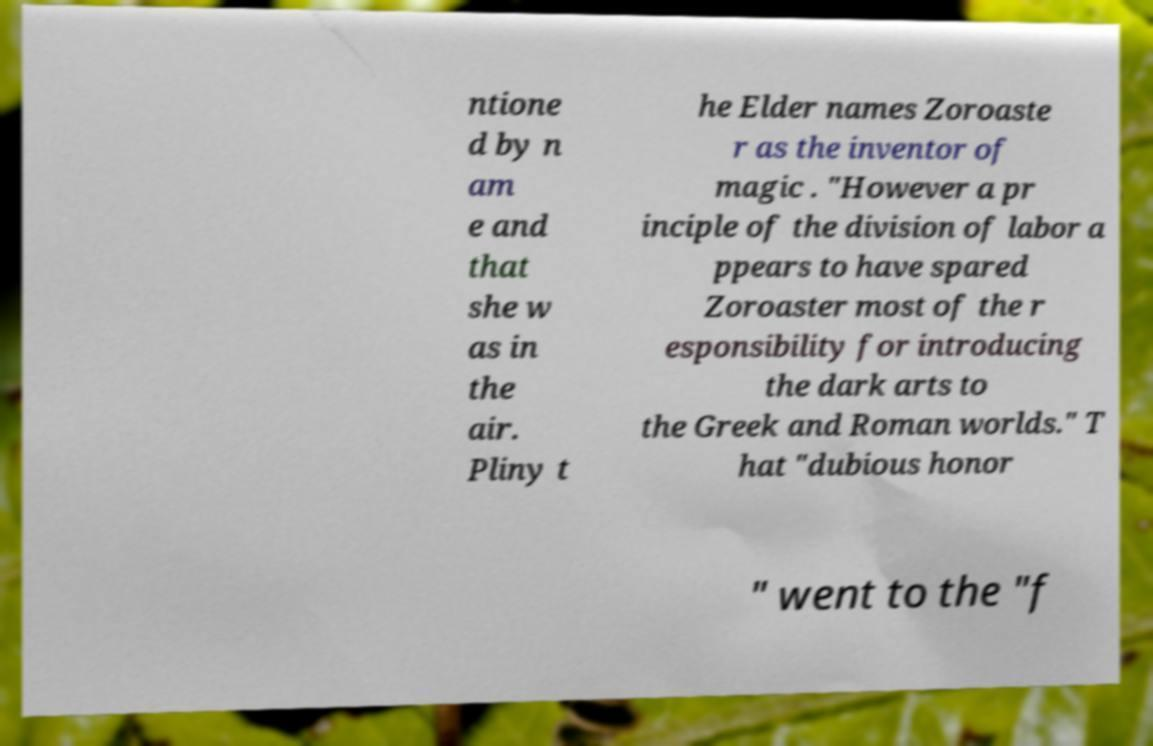Can you accurately transcribe the text from the provided image for me? ntione d by n am e and that she w as in the air. Pliny t he Elder names Zoroaste r as the inventor of magic . "However a pr inciple of the division of labor a ppears to have spared Zoroaster most of the r esponsibility for introducing the dark arts to the Greek and Roman worlds." T hat "dubious honor " went to the "f 